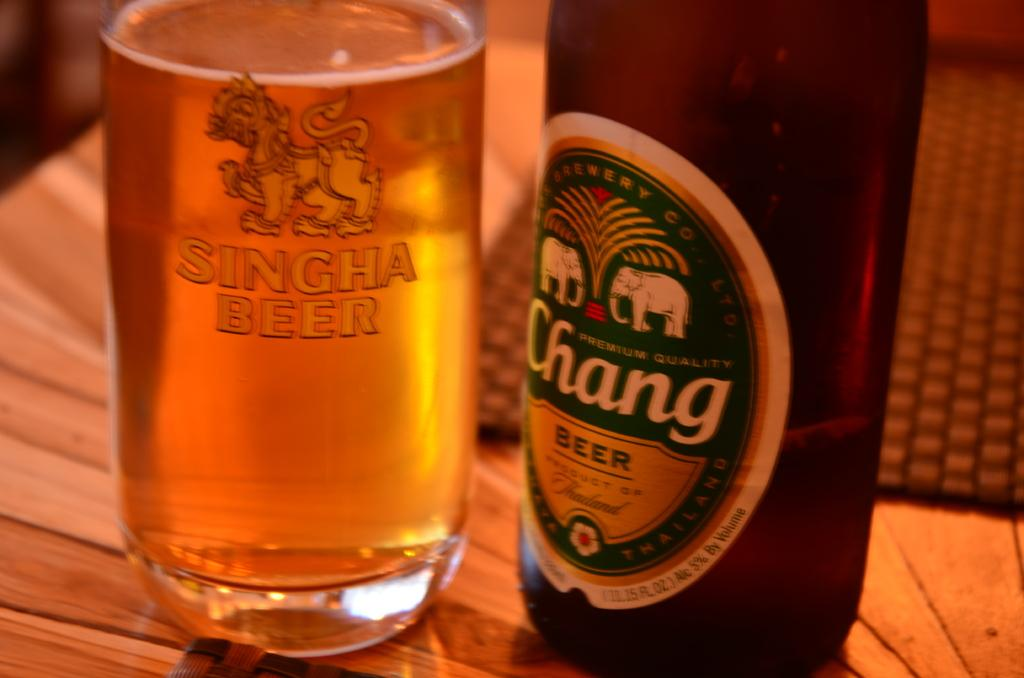<image>
Present a compact description of the photo's key features. A bottle of Chang Beer sits next to a glass of Singha Beer. 